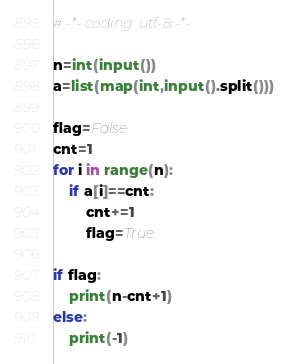Convert code to text. <code><loc_0><loc_0><loc_500><loc_500><_Python_># -*- coding: utf-8 -*-

n=int(input())
a=list(map(int,input().split()))

flag=False
cnt=1
for i in range(n):
    if a[i]==cnt:
        cnt+=1
        flag=True

if flag:
    print(n-cnt+1)
else:
    print(-1)
</code> 